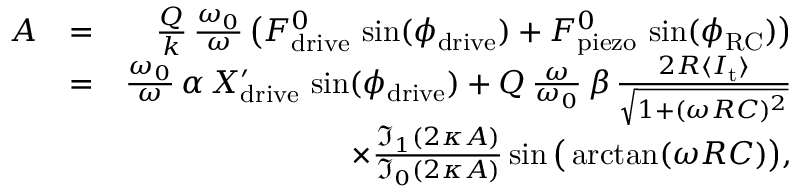<formula> <loc_0><loc_0><loc_500><loc_500>\begin{array} { r l r } { A } & { = } & { \frac { Q } { k } \, \frac { \omega _ { 0 } } { \omega } \, \left ( F _ { d r i v e } ^ { 0 } \, \sin ( \phi _ { d r i v e } ) + F _ { p i e z o } ^ { 0 } \, \sin ( \phi _ { R C } ) \right ) } \\ & { = } & { \frac { \omega _ { 0 } } { \omega } \, \alpha \, X _ { d r i v e } ^ { \prime } \, \sin ( \phi _ { d r i v e } ) + Q \, \frac { \omega } { \omega _ { 0 } } \, \beta \, \frac { 2 R \langle I _ { t } \rangle } { \sqrt { 1 + ( \omega R C ) ^ { 2 } } } } \\ & { \times \frac { \mathfrak { I } _ { 1 } ( 2 \kappa A ) } { \mathfrak { I } _ { 0 } ( 2 \kappa A ) } \sin \left ( \arctan ( \omega R C ) \right ) , } \end{array}</formula> 